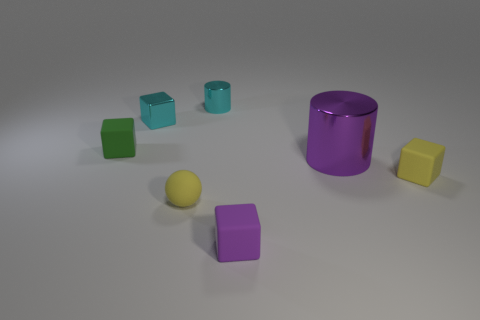There is a rubber object that is behind the matte object right of the purple object that is to the left of the big purple metallic cylinder; what is its shape?
Your answer should be very brief. Cube. Do the green object and the metallic cube have the same size?
Offer a terse response. Yes. What number of things are either cyan metal objects or yellow rubber things right of the small cyan cylinder?
Your response must be concise. 3. How many things are either cyan objects in front of the small cylinder or blocks to the right of the big purple metal cylinder?
Offer a terse response. 2. Are there any small cyan shiny objects to the right of the yellow matte sphere?
Your response must be concise. Yes. What is the color of the rubber thing that is right of the large thing that is in front of the tiny cyan thing right of the yellow rubber ball?
Provide a short and direct response. Yellow. Does the big object have the same shape as the green rubber thing?
Provide a succinct answer. No. There is a sphere that is made of the same material as the purple cube; what color is it?
Offer a very short reply. Yellow. How many things are either small yellow rubber objects that are right of the rubber ball or tiny balls?
Provide a succinct answer. 2. What is the size of the matte block that is behind the big purple thing?
Provide a succinct answer. Small. 